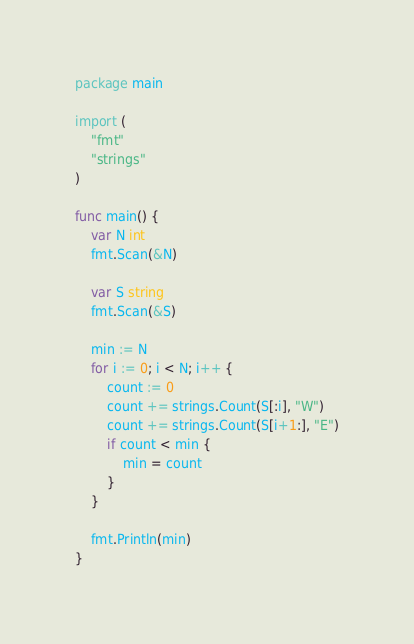Convert code to text. <code><loc_0><loc_0><loc_500><loc_500><_Go_>package main

import (
	"fmt"
	"strings"
)

func main() {
	var N int
	fmt.Scan(&N)

	var S string
	fmt.Scan(&S)

	min := N
	for i := 0; i < N; i++ {
		count := 0
		count += strings.Count(S[:i], "W")
		count += strings.Count(S[i+1:], "E")
		if count < min {
			min = count
		}
	}

	fmt.Println(min)
}
</code> 